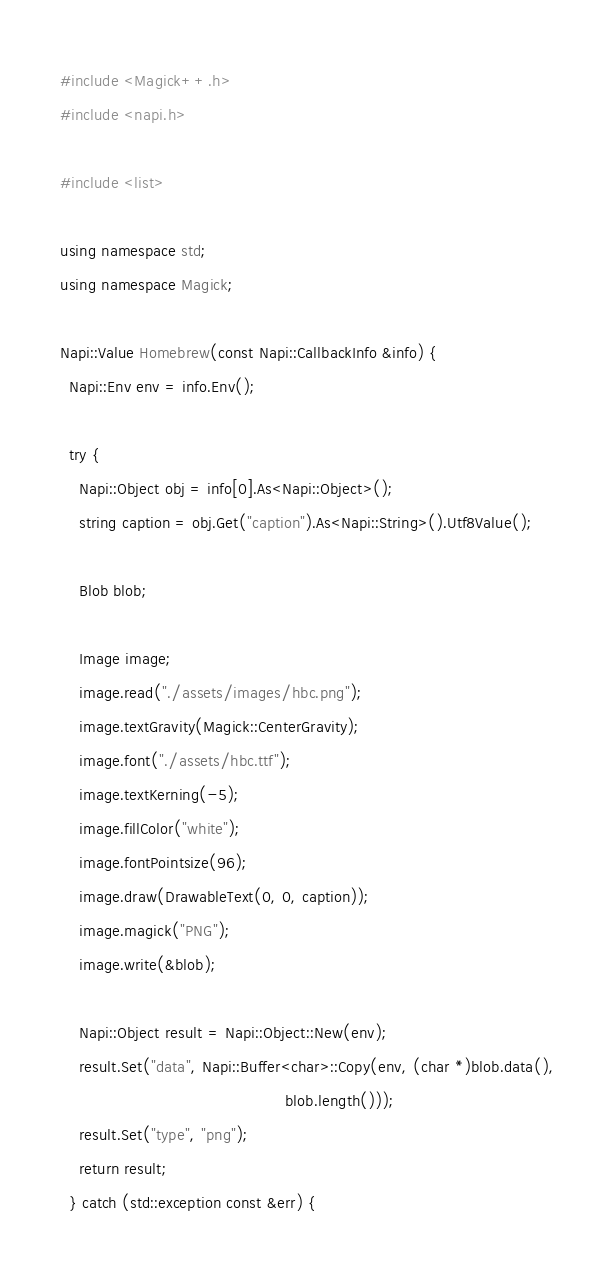Convert code to text. <code><loc_0><loc_0><loc_500><loc_500><_C++_>#include <Magick++.h>
#include <napi.h>

#include <list>

using namespace std;
using namespace Magick;

Napi::Value Homebrew(const Napi::CallbackInfo &info) {
  Napi::Env env = info.Env();

  try {
    Napi::Object obj = info[0].As<Napi::Object>();
    string caption = obj.Get("caption").As<Napi::String>().Utf8Value();

    Blob blob;

    Image image;
    image.read("./assets/images/hbc.png");
    image.textGravity(Magick::CenterGravity);
    image.font("./assets/hbc.ttf");
    image.textKerning(-5);
    image.fillColor("white");
    image.fontPointsize(96);
    image.draw(DrawableText(0, 0, caption));
    image.magick("PNG");
    image.write(&blob);

    Napi::Object result = Napi::Object::New(env);
    result.Set("data", Napi::Buffer<char>::Copy(env, (char *)blob.data(),
                                                blob.length()));
    result.Set("type", "png");
    return result;
  } catch (std::exception const &err) {</code> 